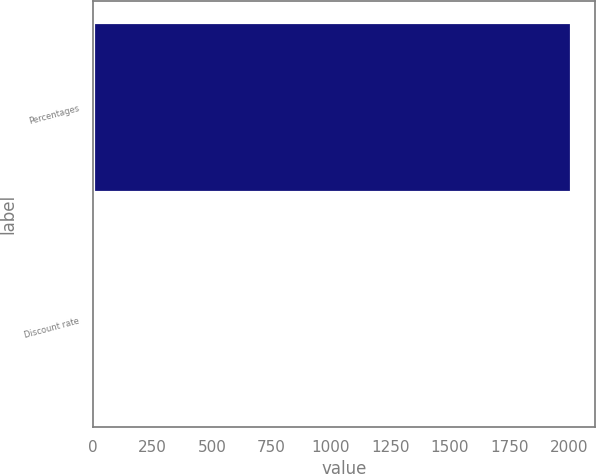Convert chart to OTSL. <chart><loc_0><loc_0><loc_500><loc_500><bar_chart><fcel>Percentages<fcel>Discount rate<nl><fcel>2011<fcel>5.9<nl></chart> 